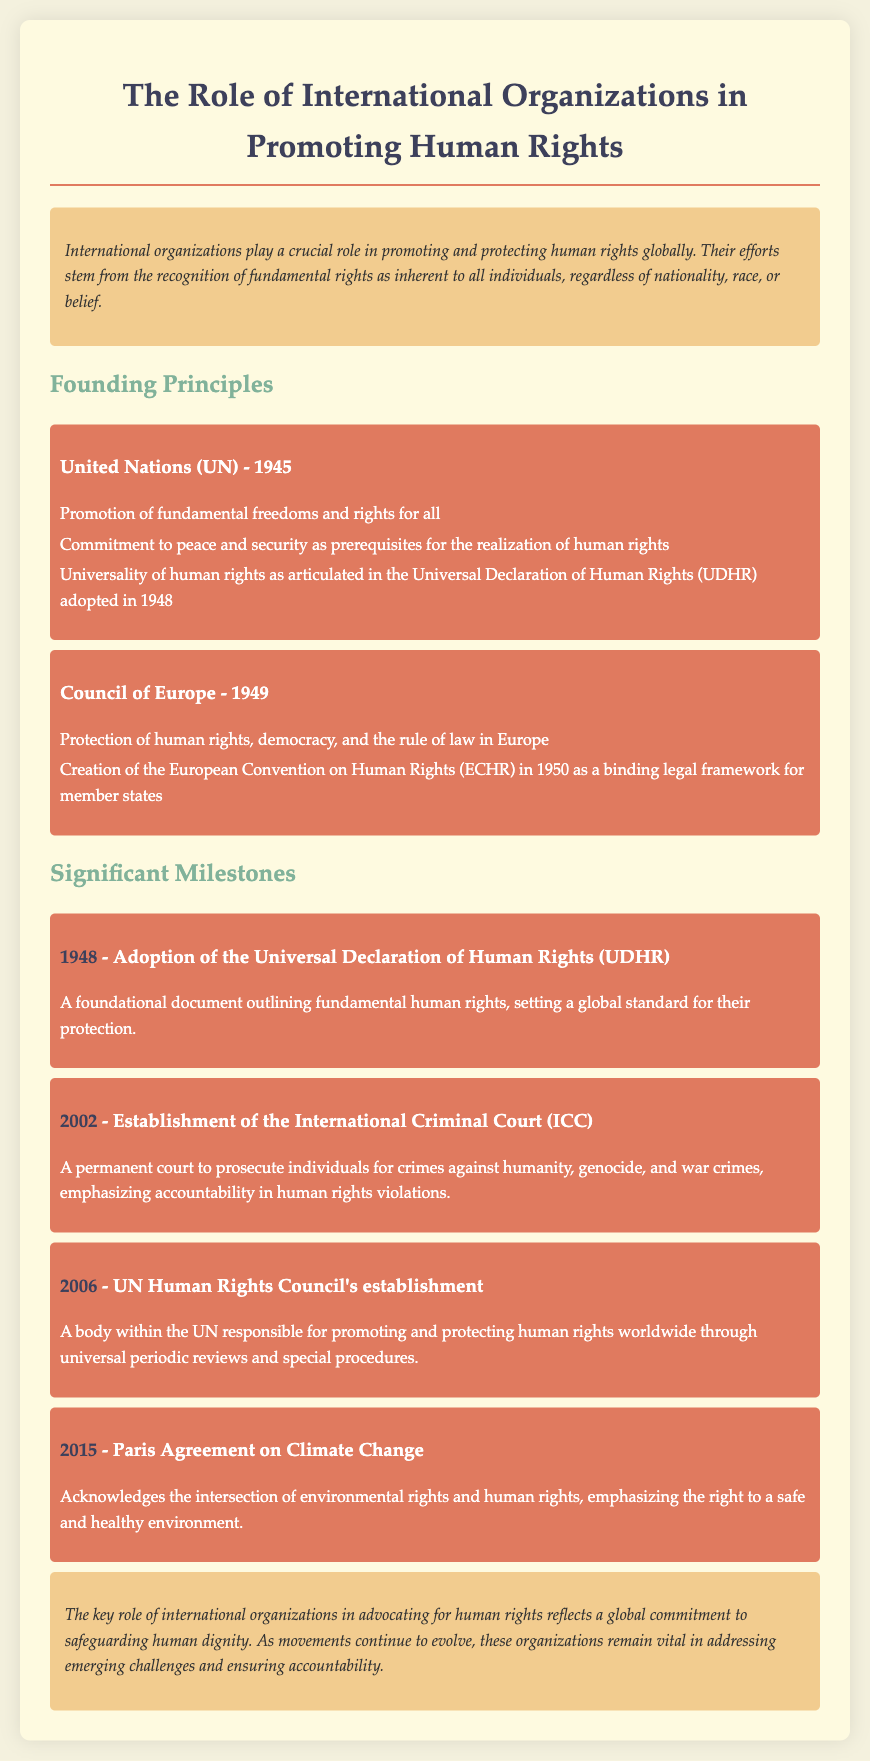what is the founding year of the United Nations? The document states that the United Nations was founded in 1945.
Answer: 1945 what document outlines fundamental human rights adopted in 1948? The Universal Declaration of Human Rights (UDHR) is mentioned as the foundational document adopted in 1948.
Answer: Universal Declaration of Human Rights (UDHR) which organization is responsible for the European Convention on Human Rights? The Council of Europe is identified as the organization behind the European Convention on Human Rights (ECHR).
Answer: Council of Europe what year was the International Criminal Court established? The document indicates that the International Criminal Court (ICC) was established in 2002.
Answer: 2002 how does the Paris Agreement on Climate Change relate to human rights? The document highlights that the Paris Agreement emphasizes the right to a safe and healthy environment, linking environmental rights with human rights.
Answer: right to a safe and healthy environment what is the main responsibility of the UN Human Rights Council? The document specifies that the UN Human Rights Council is responsible for promoting and protecting human rights worldwide.
Answer: promoting and protecting human rights which two international organizations are highlighted in the founding principles section? The founding principles section discusses the United Nations and the Council of Europe.
Answer: United Nations, Council of Europe what significant event happened in 2006 related to human rights? In 2006, the UN Human Rights Council was established according to the document.
Answer: UN Human Rights Council's establishment 